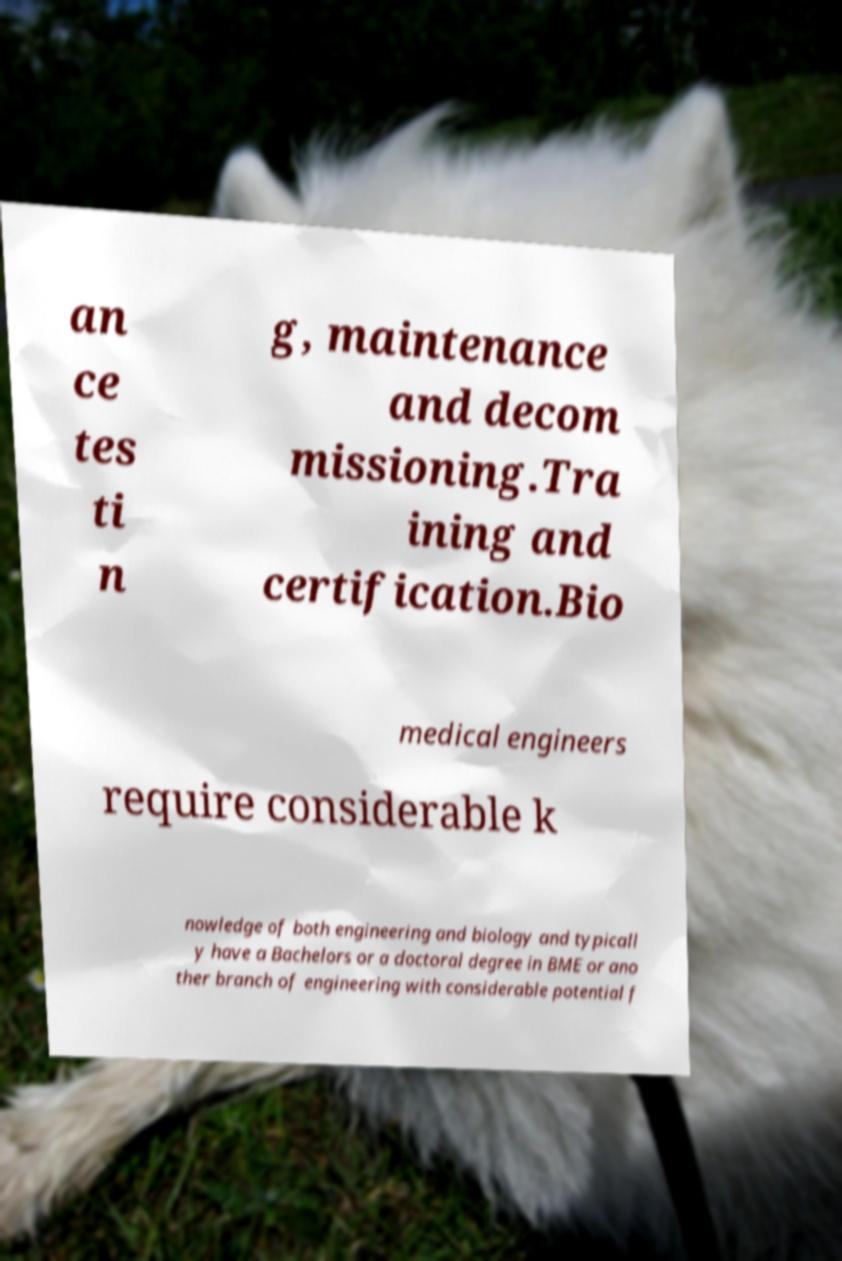Could you assist in decoding the text presented in this image and type it out clearly? an ce tes ti n g, maintenance and decom missioning.Tra ining and certification.Bio medical engineers require considerable k nowledge of both engineering and biology and typicall y have a Bachelors or a doctoral degree in BME or ano ther branch of engineering with considerable potential f 